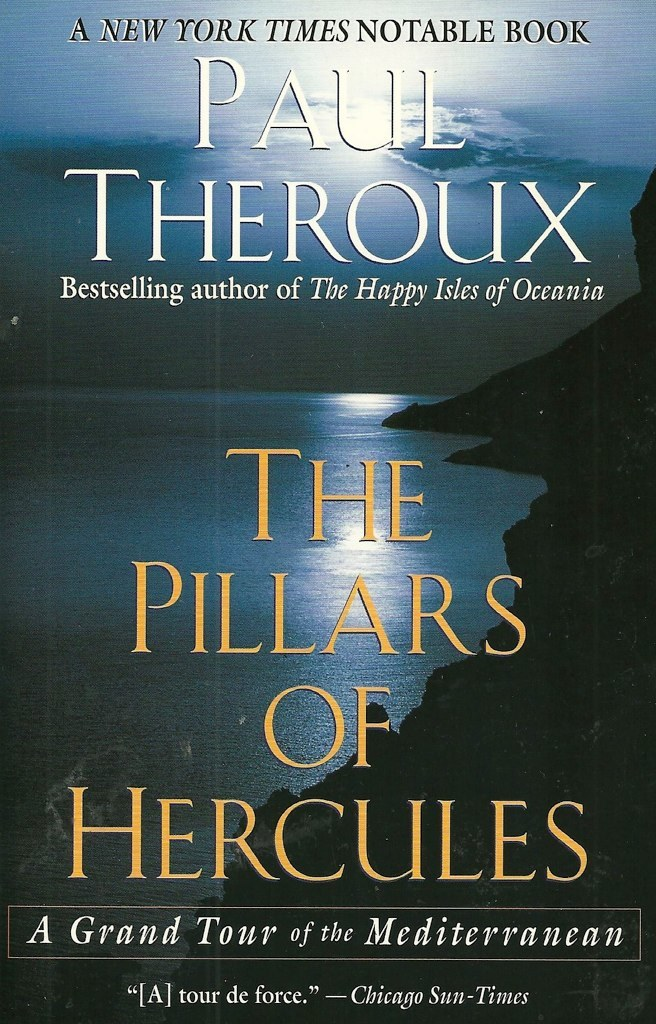What do you think is going on in this snapshot? The image is of a book cover titled 'The Pillars of Hercules' by Paul Theroux, a well-known travel writer. The cover shows a serene cliff overlooking the sea, suggesting the theme of exploration within the Mediterranean, as indicated by the subtitle 'A Grand Tour of the Mediterranean'. It's noted as a New York Times Notable Book and includes endorsements from reputable sources like the Chicago Sun-Times, praising it as a 'tour de force'. Also, it references Theroux's past success with another book, enhancing its appeal to potential readers who may admire his earlier works, thereby providing a deeper insight into the potential narrative and allure of this book. 